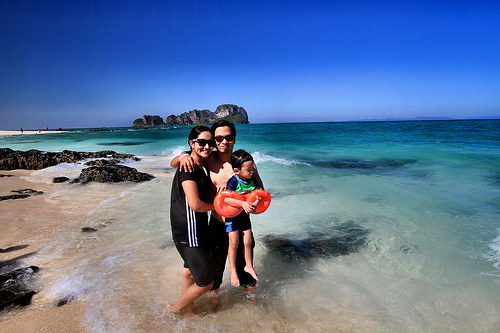<image>
Is there a boy on the ocean? No. The boy is not positioned on the ocean. They may be near each other, but the boy is not supported by or resting on top of the ocean. Is there a man to the left of the woman? Yes. From this viewpoint, the man is positioned to the left side relative to the woman. Where is the child in relation to the water? Is it in the water? No. The child is not contained within the water. These objects have a different spatial relationship. Is there a island above the man? No. The island is not positioned above the man. The vertical arrangement shows a different relationship. 